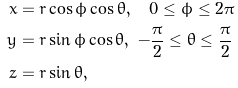<formula> <loc_0><loc_0><loc_500><loc_500>x & = r \cos \phi \cos \theta , \quad 0 \leq \phi \leq 2 \pi \\ y & = r \sin \phi \cos \theta , \ - \frac { \pi } { 2 } \leq \theta \leq \frac { \pi } { 2 } \\ z & = r \sin \theta ,</formula> 